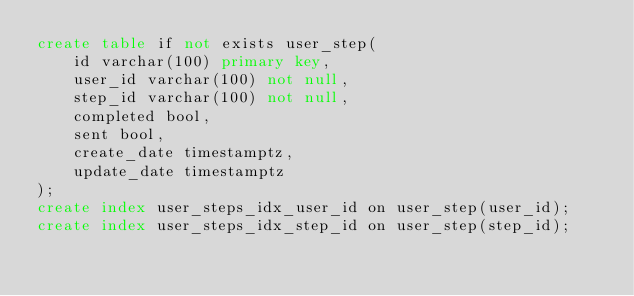<code> <loc_0><loc_0><loc_500><loc_500><_SQL_>create table if not exists user_step(
    id varchar(100) primary key,
    user_id varchar(100) not null,
    step_id varchar(100) not null,
    completed bool,
    sent bool,
    create_date timestamptz,
    update_date timestamptz
);
create index user_steps_idx_user_id on user_step(user_id);
create index user_steps_idx_step_id on user_step(step_id);</code> 